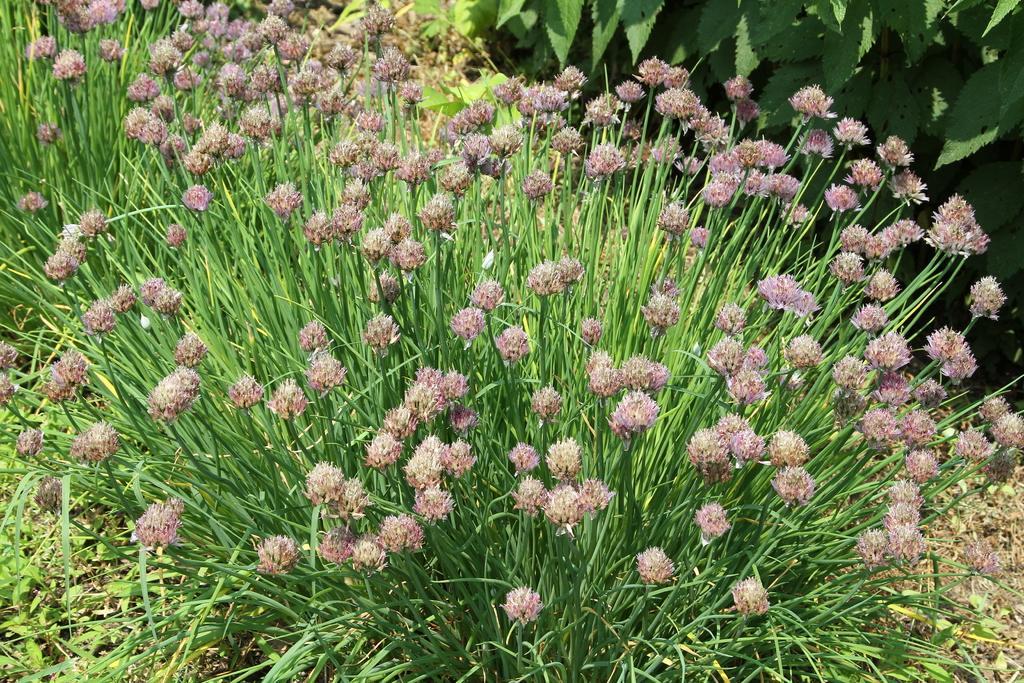Please provide a concise description of this image. In this image, we can see plants with flowers. 